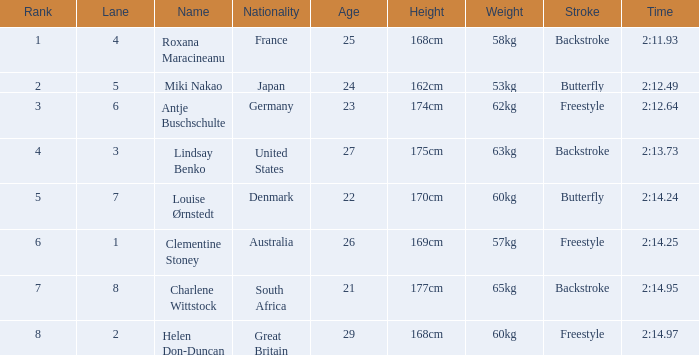What shows for nationality when there is a rank larger than 6, and a Time of 2:14.95? South Africa. 